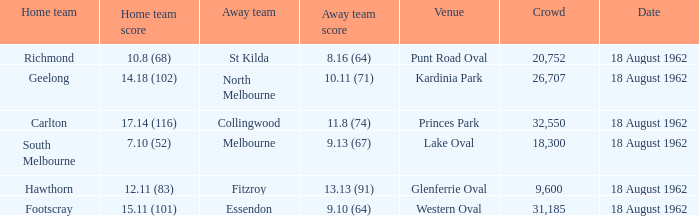In which setting where the home team recorded 1 None. 